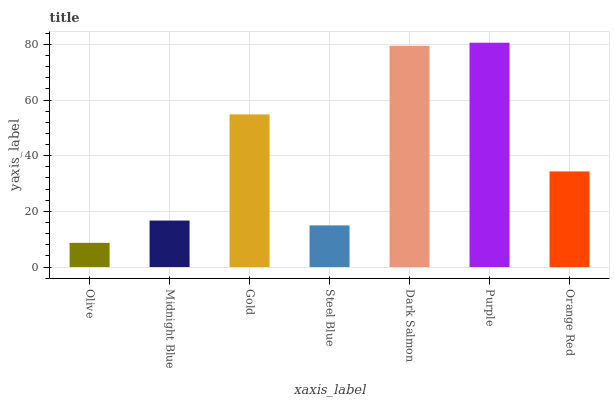Is Midnight Blue the minimum?
Answer yes or no. No. Is Midnight Blue the maximum?
Answer yes or no. No. Is Midnight Blue greater than Olive?
Answer yes or no. Yes. Is Olive less than Midnight Blue?
Answer yes or no. Yes. Is Olive greater than Midnight Blue?
Answer yes or no. No. Is Midnight Blue less than Olive?
Answer yes or no. No. Is Orange Red the high median?
Answer yes or no. Yes. Is Orange Red the low median?
Answer yes or no. Yes. Is Steel Blue the high median?
Answer yes or no. No. Is Midnight Blue the low median?
Answer yes or no. No. 